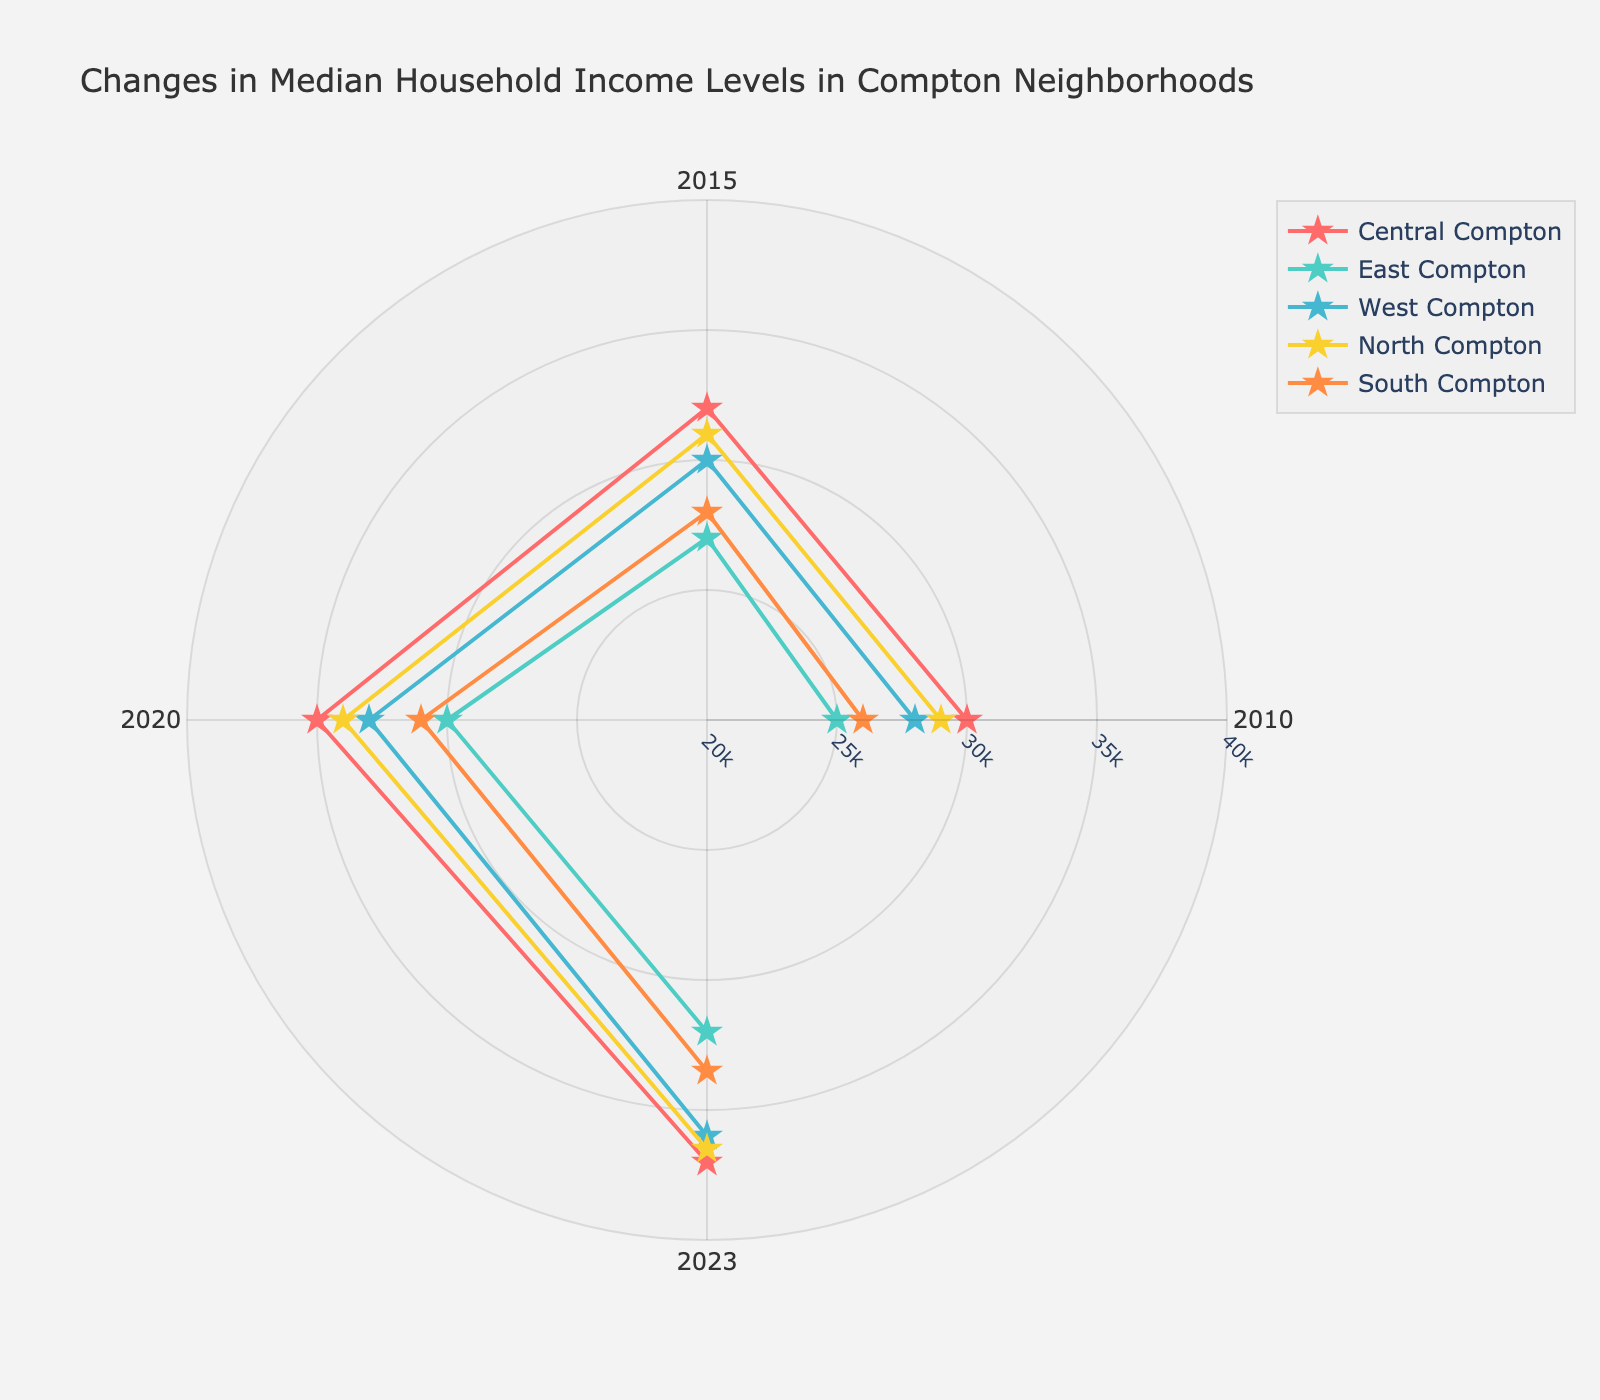What is the title of the chart? The title of the chart is displayed at the top and reads, "Changes in Median Household Income Levels in Compton Neighborhoods."
Answer: Changes in Median Household Income Levels in Compton Neighborhoods How many years are compared in the chart? The chart uses angles to represent different years, with 0, 90, 180, and 270 degrees indicating the years 2010, 2015, 2020, and 2023, respectively. Thus, four years are compared in the chart.
Answer: Four Which neighborhood had the highest median household income in 2023? By observing the radial distance of the markers at the 270-degree angle (representing 2023), North Compton's marker is the furthest out, indicating the highest median household income.
Answer: North Compton How did the median household income in East Compton change from 2010 to 2023? For East Compton, compare the radial distances of markers at angles 0 (2010) and 270 (2023). The income increased from $25,000 in 2010 to $32,000 in 2023. The increase was $7,000.
Answer: Increased by $7,000 Which neighborhood shows the largest increase in median household income from 2010 to 2023? Examine the income levels for each neighborhood at angles 0 (2010) and 270 (2023) to find the largest difference. Central Compton increases from $30,000 to $37,000, showing an increase of $7,000. This is the highest increase among all neighborhoods.
Answer: Central Compton In which year did South Compton have the lowest median household income? Look at the markers for South Compton at different angles. The marker at 0 degrees (2010) is the closest to the center, indicating the lowest income of $26,000.
Answer: 2010 Compare the median household income between West Compton and Central Compton in 2020. Which one is higher? Look at the markers for both neighborhoods at the 180-degree angle (2020). Central Compton's marker is slightly further out than West Compton's, indicating a higher median household income of $35,000 vs. $33,000.
Answer: Central Compton What is the average income increase for South Compton from 2010 to 2023? Calculate the difference between 2023 and 2010 for South Compton ($33,500 - $26,000 = $7,500) and divide by the number of years (2023 - 2010 = 13 years). The average annual increase is $7,500 / 13 ≈ $576.92.
Answer: Approximately $576.92 per year How does North Compton's income trend compare to East Compton's between 2010 and 2023? Look at the markers at angles 0 and 270 for both neighborhoods. North Compton increased from $29,000 to $36,500, a $7,500 growth. East Compton increased from $25,000 to $32,000, a $7,000 growth. North Compton saw a slightly larger income increase than East Compton.
Answer: North Compton had a slightly larger increase Which neighborhood had the most consistent income growth over the years? By observing the smoothness and angle step distribution in each neighborhood's line connections, South Compton shows a steady and even growth pattern, with incremental increases from 2010 to 2023.
Answer: South Compton 